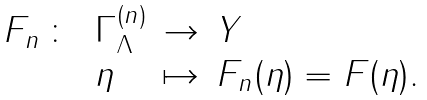<formula> <loc_0><loc_0><loc_500><loc_500>\begin{array} { l l l l } F _ { n } \, \colon \, & \Gamma _ { \Lambda } ^ { ( n ) } & \to & Y \\ & \eta & \mapsto & F _ { n } ( \eta ) = F ( \eta ) . \end{array}</formula> 